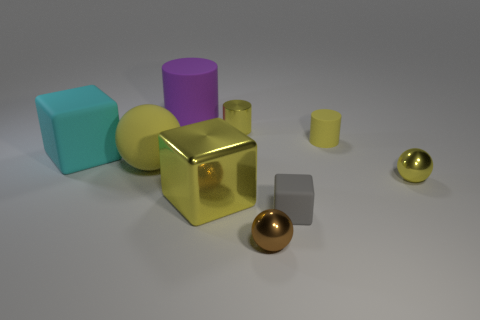Can you identify the different materials of the objects depicted? The objects seem to be made of materials such as metal, given the reflective gold and copper cylinders, and possibly plastic or painted wood for the matte-finished cubes and the tall purple cylinder. Their surfaces suggest these material properties by the way they interact with light. How does the texture of each object contribute to the overall aesthetic of the scene? The contrasting textures, from the smooth and reflective metals to the subdued matte of the other shapes, play off of each other to bring about a visually engaging scene that entices the eye to explore each object's individual character within the collective tableau. 